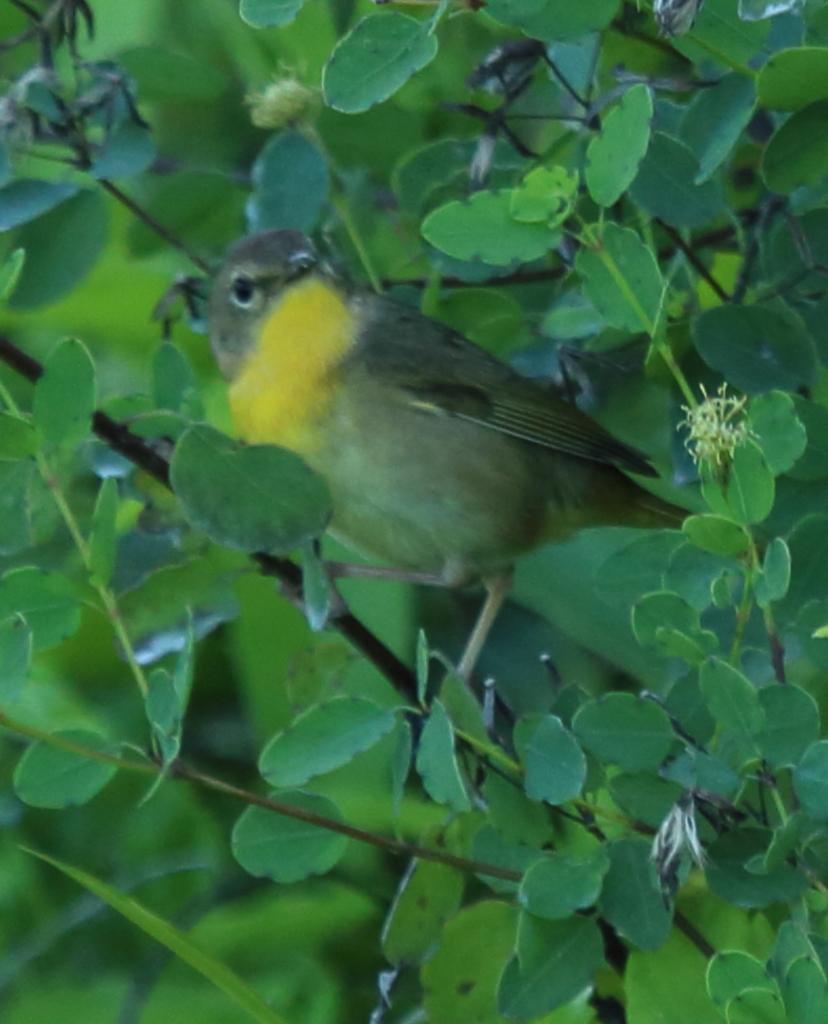Can you describe this image briefly? In this image we can see a bird which is of brown and yellow color is on the stem and there are leaves. 